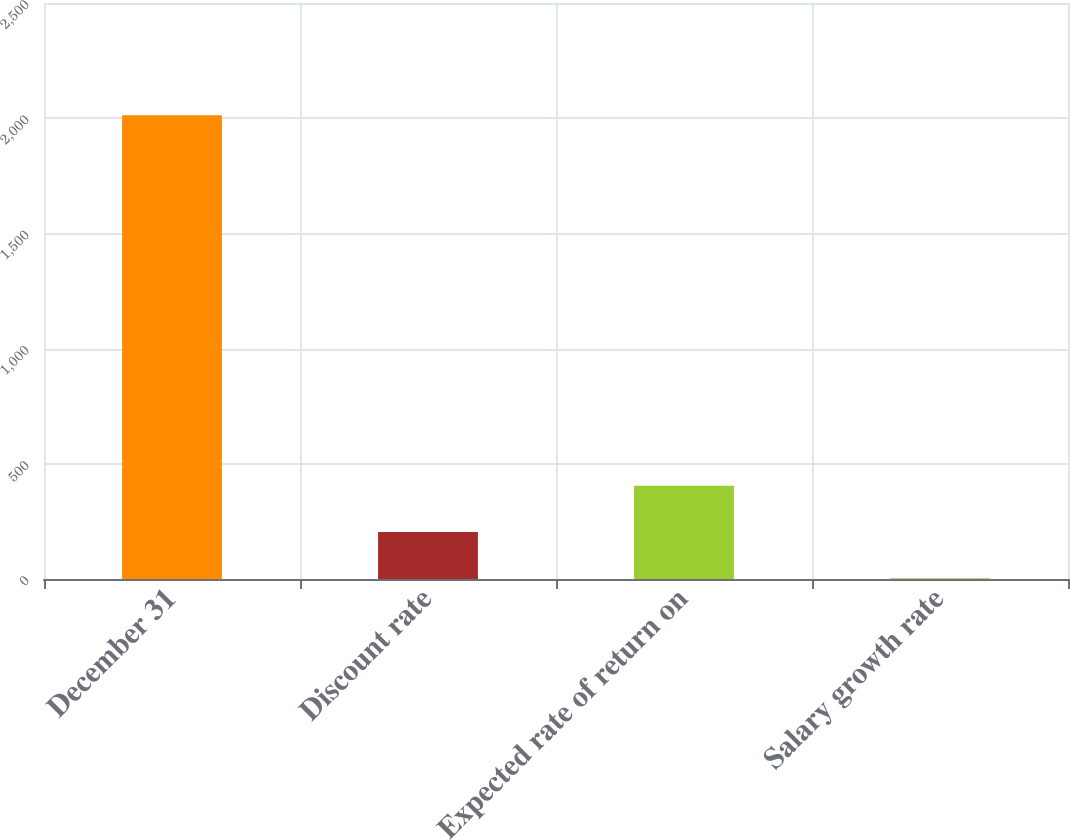Convert chart to OTSL. <chart><loc_0><loc_0><loc_500><loc_500><bar_chart><fcel>December 31<fcel>Discount rate<fcel>Expected rate of return on<fcel>Salary growth rate<nl><fcel>2013<fcel>204.27<fcel>405.24<fcel>3.3<nl></chart> 